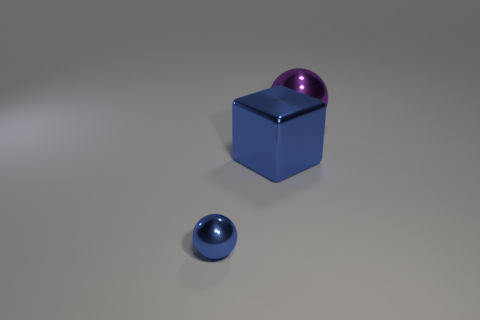How are the objects arranged in relation to each other? The objects appear to be positioned deliberately on a flat surface, with ample space between them. The blue cube is placed centrally, with the purple sphere resting on top towards one corner, and the small blue sphere is positioned independently on the left, ahead of the cube. 